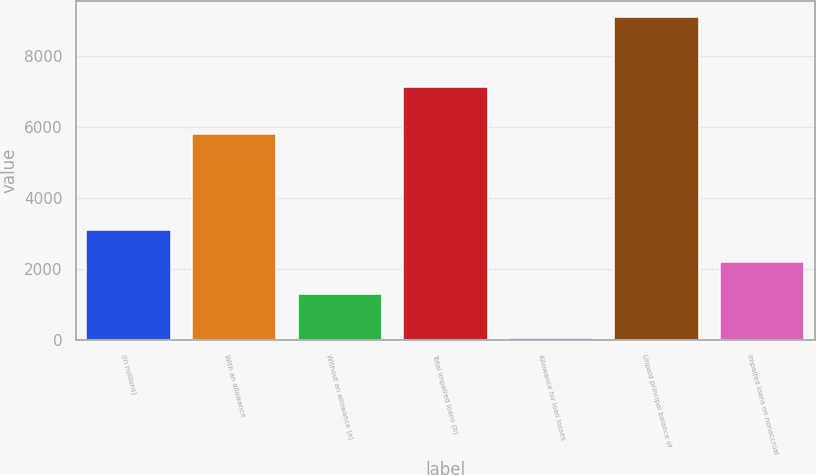Convert chart. <chart><loc_0><loc_0><loc_500><loc_500><bar_chart><fcel>(in millions)<fcel>With an allowance<fcel>Without an allowance (a)<fcel>Total impaired loans (b)<fcel>Allowance for loan losses<fcel>Unpaid principal balance of<fcel>Impaired loans on nonaccrual<nl><fcel>3113<fcel>5810<fcel>1308<fcel>7118<fcel>70<fcel>9095<fcel>2210.5<nl></chart> 